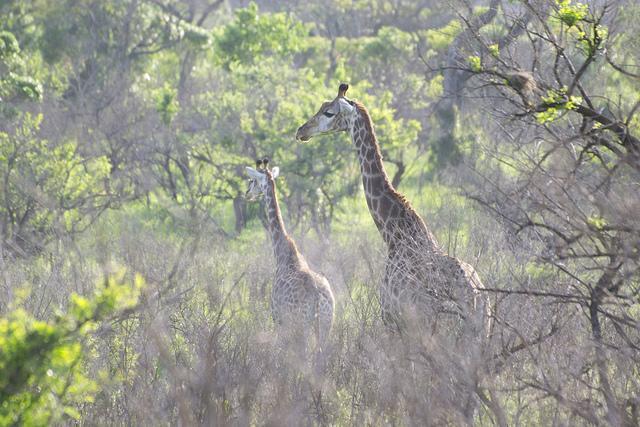How many giraffes can you see?
Give a very brief answer. 2. 